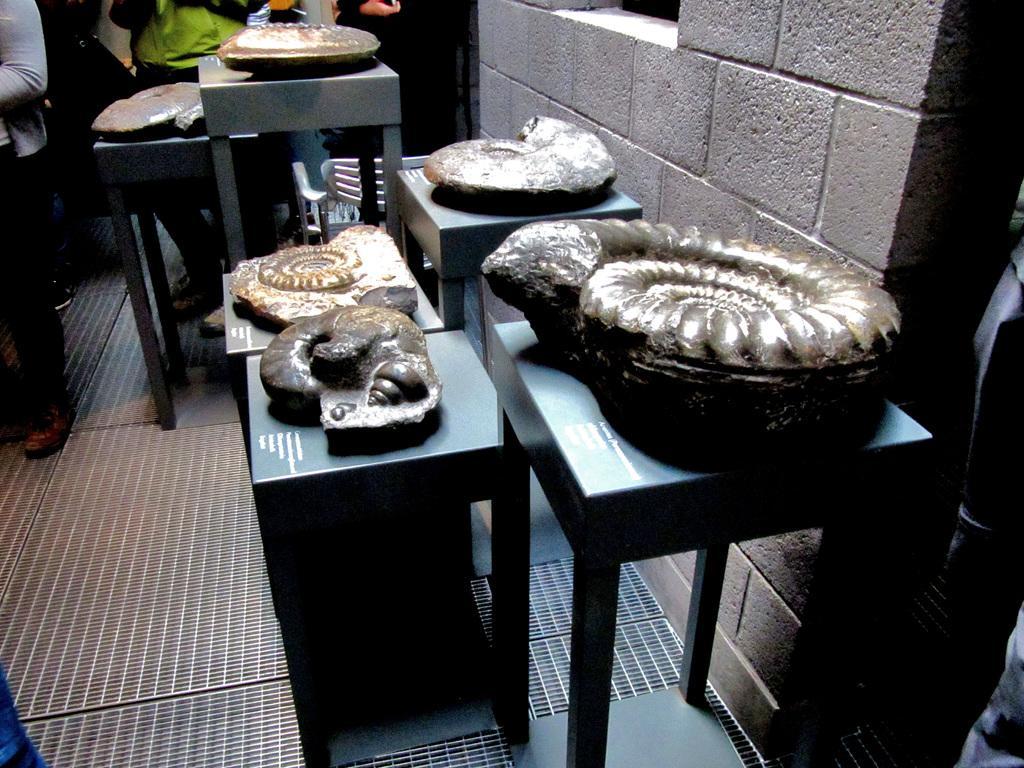Can you describe this image briefly? In this image we can see few people. There are many objects placed on the tables. There is a wall at the right side of the image. 